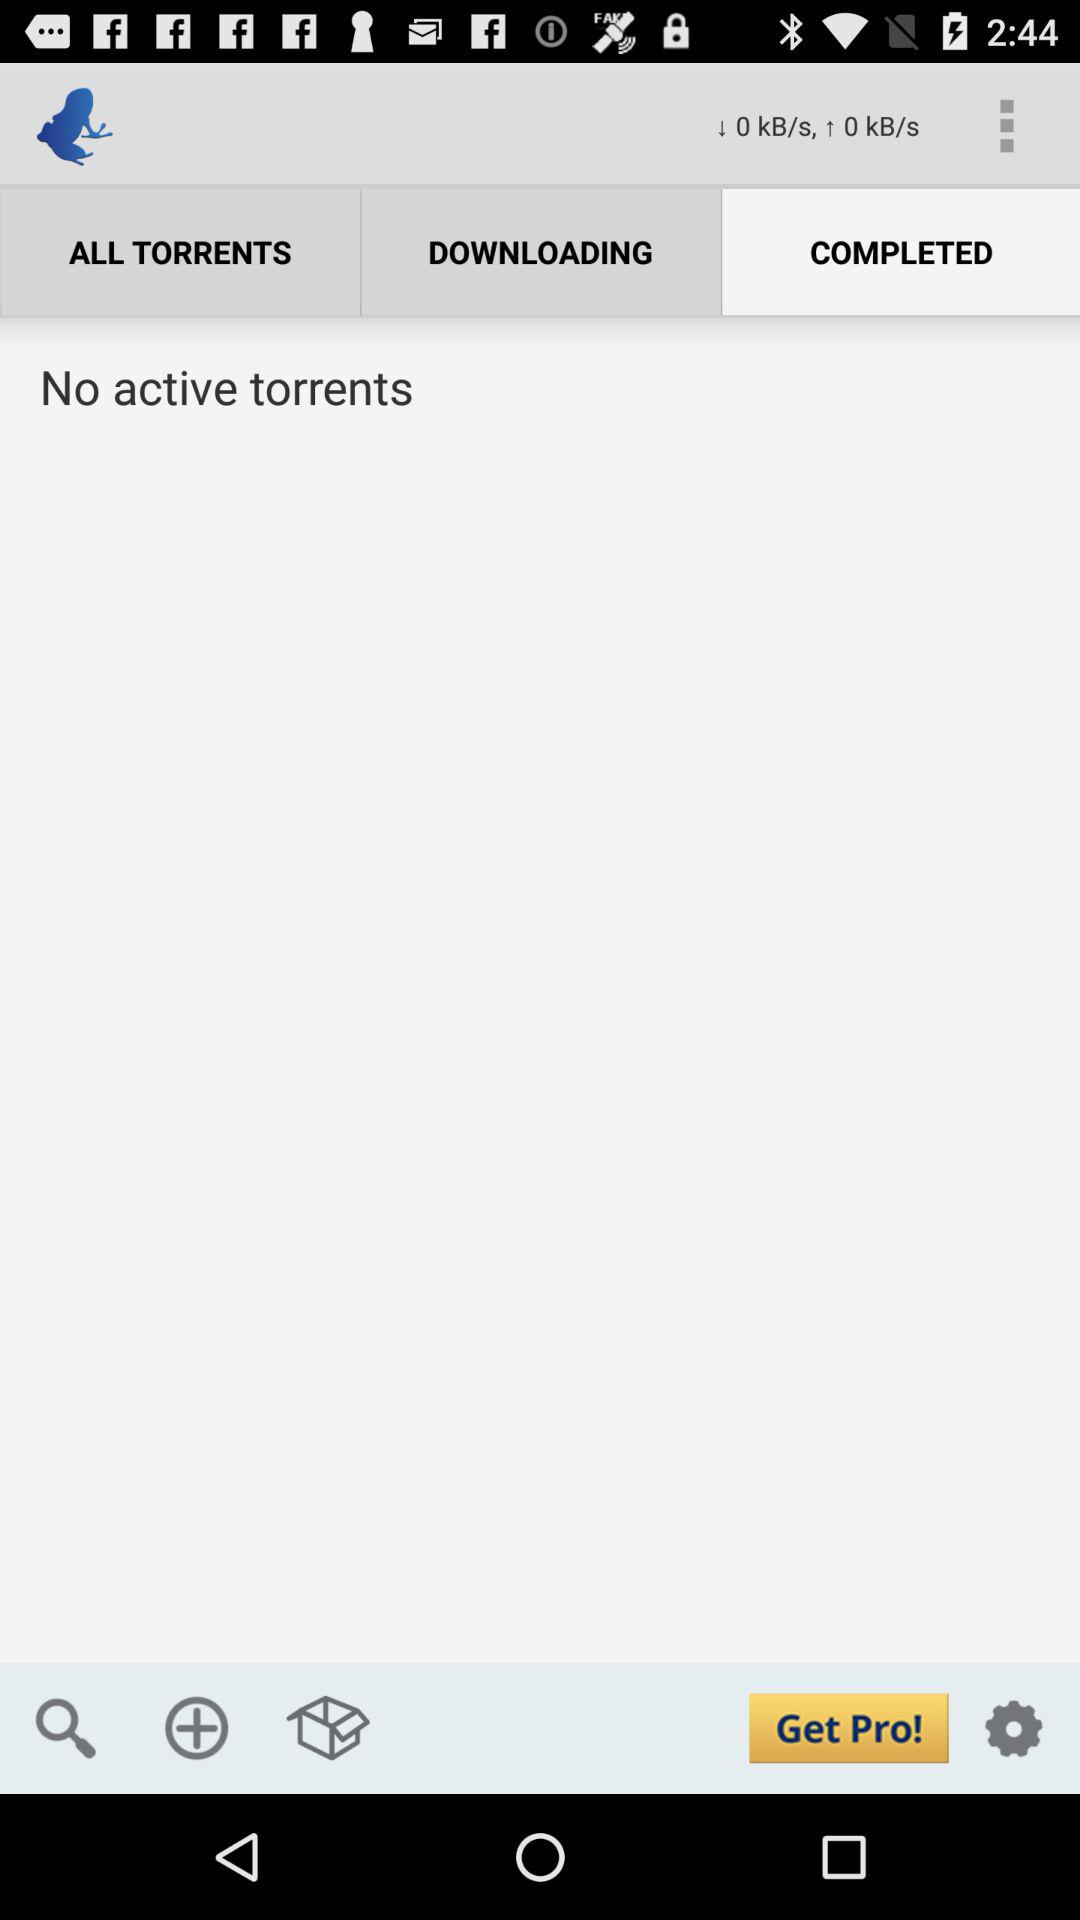Can you tell what time it is from this image? Yes, the time displayed in the top right corner of the image shows it's 2:44. 